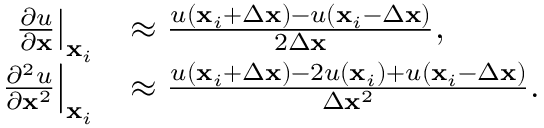<formula> <loc_0><loc_0><loc_500><loc_500>\begin{array} { r l } { \frac { \partial u } { \partial x } \right | _ { x _ { i } } } & { \approx \frac { u \left ( x _ { i } + \Delta x \right ) - u \left ( x _ { i } - \Delta x \right ) } { 2 \Delta x } , } \\ { \frac { \partial ^ { 2 } u } { \partial x ^ { 2 } } \right | _ { x _ { i } } } & { \approx \frac { u \left ( x _ { i } + \Delta x \right ) - 2 u \left ( x _ { i } \right ) + u \left ( x _ { i } - \Delta x \right ) } { \Delta x ^ { 2 } } . } \end{array}</formula> 